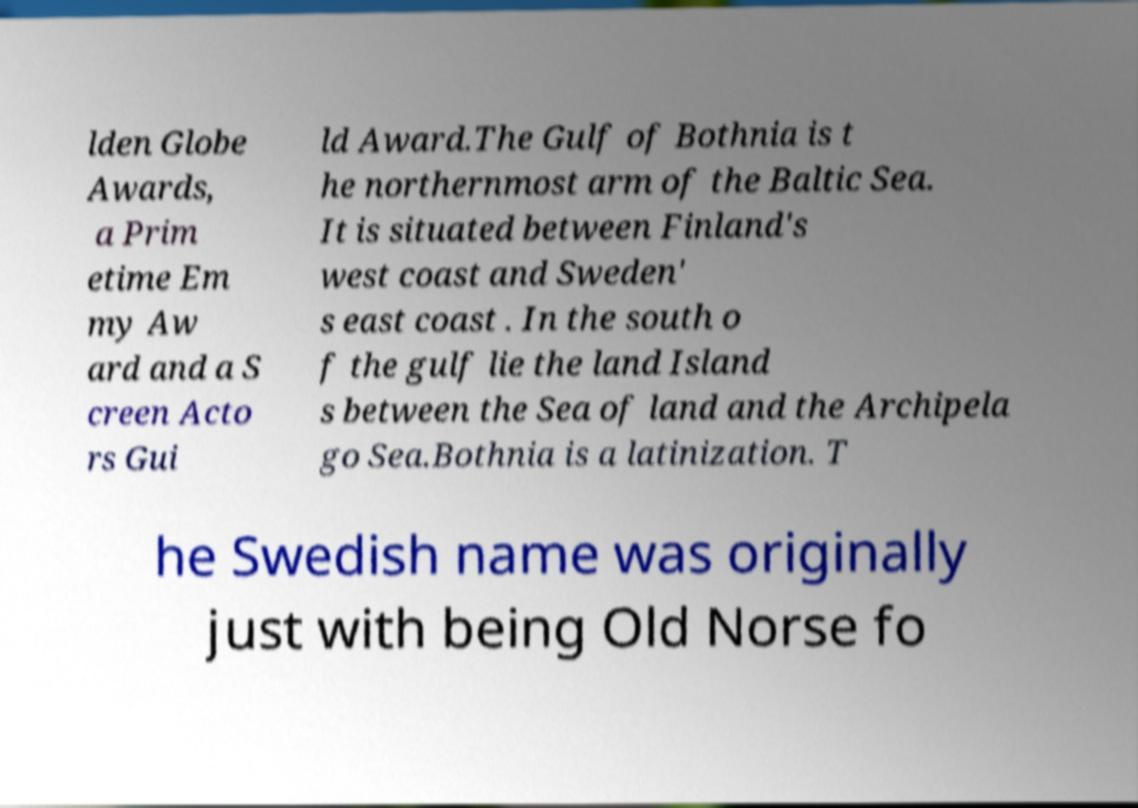I need the written content from this picture converted into text. Can you do that? lden Globe Awards, a Prim etime Em my Aw ard and a S creen Acto rs Gui ld Award.The Gulf of Bothnia is t he northernmost arm of the Baltic Sea. It is situated between Finland's west coast and Sweden' s east coast . In the south o f the gulf lie the land Island s between the Sea of land and the Archipela go Sea.Bothnia is a latinization. T he Swedish name was originally just with being Old Norse fo 